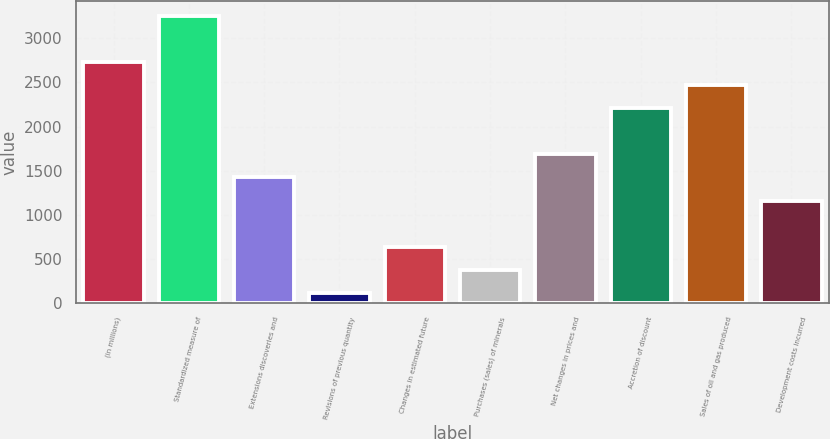Convert chart to OTSL. <chart><loc_0><loc_0><loc_500><loc_500><bar_chart><fcel>(in millions)<fcel>Standardized measure of<fcel>Extensions discoveries and<fcel>Revisions of previous quantity<fcel>Changes in estimated future<fcel>Purchases (sales) of minerals<fcel>Net changes in prices and<fcel>Accretion of discount<fcel>Sales of oil and gas produced<fcel>Development costs incurred<nl><fcel>2732<fcel>3255.4<fcel>1423.5<fcel>115<fcel>638.4<fcel>376.7<fcel>1685.2<fcel>2208.6<fcel>2470.3<fcel>1161.8<nl></chart> 